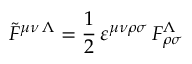<formula> <loc_0><loc_0><loc_500><loc_500>{ \tilde { F } } ^ { \mu \nu \, \Lambda } = { \frac { 1 } { 2 } } \, \varepsilon ^ { \mu \nu \rho \sigma } \, F _ { \rho \sigma } ^ { \Lambda }</formula> 